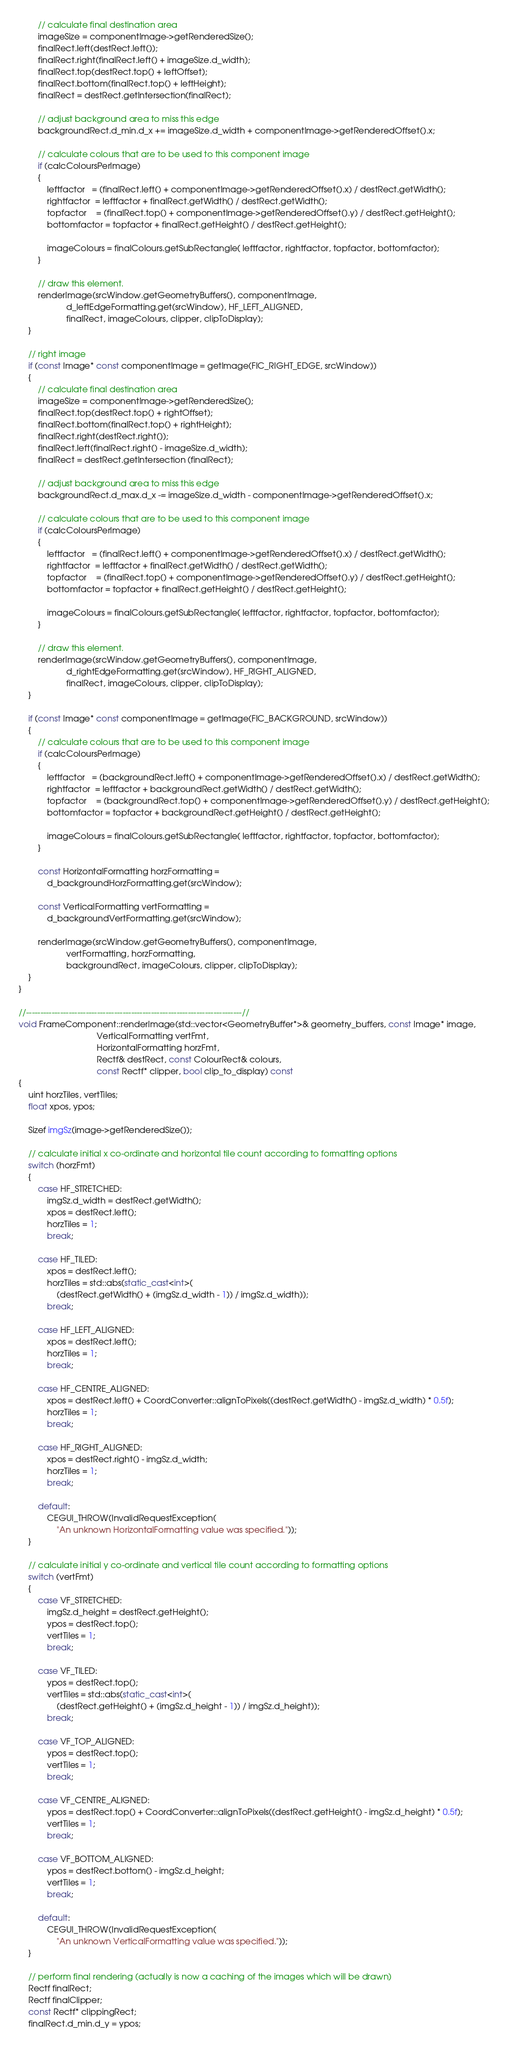Convert code to text. <code><loc_0><loc_0><loc_500><loc_500><_C++_>        // calculate final destination area
        imageSize = componentImage->getRenderedSize();
        finalRect.left(destRect.left());
        finalRect.right(finalRect.left() + imageSize.d_width);
        finalRect.top(destRect.top() + leftOffset);
        finalRect.bottom(finalRect.top() + leftHeight);
        finalRect = destRect.getIntersection(finalRect);

        // adjust background area to miss this edge
        backgroundRect.d_min.d_x += imageSize.d_width + componentImage->getRenderedOffset().x;

        // calculate colours that are to be used to this component image
        if (calcColoursPerImage)
        {
            leftfactor   = (finalRect.left() + componentImage->getRenderedOffset().x) / destRect.getWidth();
            rightfactor  = leftfactor + finalRect.getWidth() / destRect.getWidth();
            topfactor    = (finalRect.top() + componentImage->getRenderedOffset().y) / destRect.getHeight();
            bottomfactor = topfactor + finalRect.getHeight() / destRect.getHeight();

            imageColours = finalColours.getSubRectangle( leftfactor, rightfactor, topfactor, bottomfactor);
        }

        // draw this element.
        renderImage(srcWindow.getGeometryBuffers(), componentImage,
                    d_leftEdgeFormatting.get(srcWindow), HF_LEFT_ALIGNED,
                    finalRect, imageColours, clipper, clipToDisplay);
    }

    // right image
    if (const Image* const componentImage = getImage(FIC_RIGHT_EDGE, srcWindow))
    {
        // calculate final destination area
        imageSize = componentImage->getRenderedSize();
        finalRect.top(destRect.top() + rightOffset);
        finalRect.bottom(finalRect.top() + rightHeight);
        finalRect.right(destRect.right());
        finalRect.left(finalRect.right() - imageSize.d_width);
        finalRect = destRect.getIntersection (finalRect);

        // adjust background area to miss this edge
        backgroundRect.d_max.d_x -= imageSize.d_width - componentImage->getRenderedOffset().x;

        // calculate colours that are to be used to this component image
        if (calcColoursPerImage)
        {
            leftfactor   = (finalRect.left() + componentImage->getRenderedOffset().x) / destRect.getWidth();
            rightfactor  = leftfactor + finalRect.getWidth() / destRect.getWidth();
            topfactor    = (finalRect.top() + componentImage->getRenderedOffset().y) / destRect.getHeight();
            bottomfactor = topfactor + finalRect.getHeight() / destRect.getHeight();

            imageColours = finalColours.getSubRectangle( leftfactor, rightfactor, topfactor, bottomfactor);
        }

        // draw this element.
        renderImage(srcWindow.getGeometryBuffers(), componentImage,
                    d_rightEdgeFormatting.get(srcWindow), HF_RIGHT_ALIGNED,
                    finalRect, imageColours, clipper, clipToDisplay);
    }

    if (const Image* const componentImage = getImage(FIC_BACKGROUND, srcWindow))
    {
        // calculate colours that are to be used to this component image
        if (calcColoursPerImage)
        {
            leftfactor   = (backgroundRect.left() + componentImage->getRenderedOffset().x) / destRect.getWidth();
            rightfactor  = leftfactor + backgroundRect.getWidth() / destRect.getWidth();
            topfactor    = (backgroundRect.top() + componentImage->getRenderedOffset().y) / destRect.getHeight();
            bottomfactor = topfactor + backgroundRect.getHeight() / destRect.getHeight();

            imageColours = finalColours.getSubRectangle( leftfactor, rightfactor, topfactor, bottomfactor);
        }

        const HorizontalFormatting horzFormatting =
            d_backgroundHorzFormatting.get(srcWindow);

        const VerticalFormatting vertFormatting =
            d_backgroundVertFormatting.get(srcWindow);

        renderImage(srcWindow.getGeometryBuffers(), componentImage,
                    vertFormatting, horzFormatting,
                    backgroundRect, imageColours, clipper, clipToDisplay);
    }
}

//----------------------------------------------------------------------------//
void FrameComponent::renderImage(std::vector<GeometryBuffer*>& geometry_buffers, const Image* image,
                                 VerticalFormatting vertFmt,
                                 HorizontalFormatting horzFmt,
                                 Rectf& destRect, const ColourRect& colours,
                                 const Rectf* clipper, bool clip_to_display) const
{
    uint horzTiles, vertTiles;
    float xpos, ypos;

    Sizef imgSz(image->getRenderedSize());

    // calculate initial x co-ordinate and horizontal tile count according to formatting options
    switch (horzFmt)
    {
        case HF_STRETCHED:
            imgSz.d_width = destRect.getWidth();
            xpos = destRect.left();
            horzTiles = 1;
            break;

        case HF_TILED:
            xpos = destRect.left();
            horzTiles = std::abs(static_cast<int>(
                (destRect.getWidth() + (imgSz.d_width - 1)) / imgSz.d_width));
            break;

        case HF_LEFT_ALIGNED:
            xpos = destRect.left();
            horzTiles = 1;
            break;

        case HF_CENTRE_ALIGNED:
            xpos = destRect.left() + CoordConverter::alignToPixels((destRect.getWidth() - imgSz.d_width) * 0.5f);
            horzTiles = 1;
            break;

        case HF_RIGHT_ALIGNED:
            xpos = destRect.right() - imgSz.d_width;
            horzTiles = 1;
            break;

        default:
            CEGUI_THROW(InvalidRequestException(
                "An unknown HorizontalFormatting value was specified."));
    }

    // calculate initial y co-ordinate and vertical tile count according to formatting options
    switch (vertFmt)
    {
        case VF_STRETCHED:
            imgSz.d_height = destRect.getHeight();
            ypos = destRect.top();
            vertTiles = 1;
            break;

        case VF_TILED:
            ypos = destRect.top();
            vertTiles = std::abs(static_cast<int>(
                (destRect.getHeight() + (imgSz.d_height - 1)) / imgSz.d_height));
            break;

        case VF_TOP_ALIGNED:
            ypos = destRect.top();
            vertTiles = 1;
            break;

        case VF_CENTRE_ALIGNED:
            ypos = destRect.top() + CoordConverter::alignToPixels((destRect.getHeight() - imgSz.d_height) * 0.5f);
            vertTiles = 1;
            break;

        case VF_BOTTOM_ALIGNED:
            ypos = destRect.bottom() - imgSz.d_height;
            vertTiles = 1;
            break;

        default:
            CEGUI_THROW(InvalidRequestException(
                "An unknown VerticalFormatting value was specified."));
    }

    // perform final rendering (actually is now a caching of the images which will be drawn)
    Rectf finalRect;
    Rectf finalClipper;
    const Rectf* clippingRect;
    finalRect.d_min.d_y = ypos;</code> 